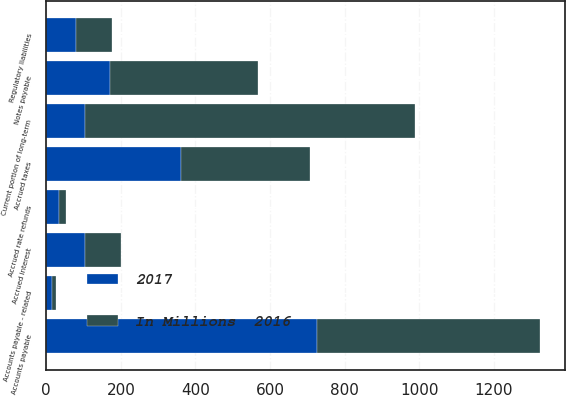Convert chart. <chart><loc_0><loc_0><loc_500><loc_500><stacked_bar_chart><ecel><fcel>Current portion of long-term<fcel>Notes payable<fcel>Accounts payable<fcel>Accounts payable - related<fcel>Accrued rate refunds<fcel>Accrued interest<fcel>Accrued taxes<fcel>Regulatory liabilities<nl><fcel>2017<fcel>103<fcel>170<fcel>725<fcel>15<fcel>33<fcel>103<fcel>360<fcel>80<nl><fcel>In Millions  2016<fcel>886<fcel>398<fcel>598<fcel>12<fcel>21<fcel>98<fcel>348<fcel>95<nl></chart> 